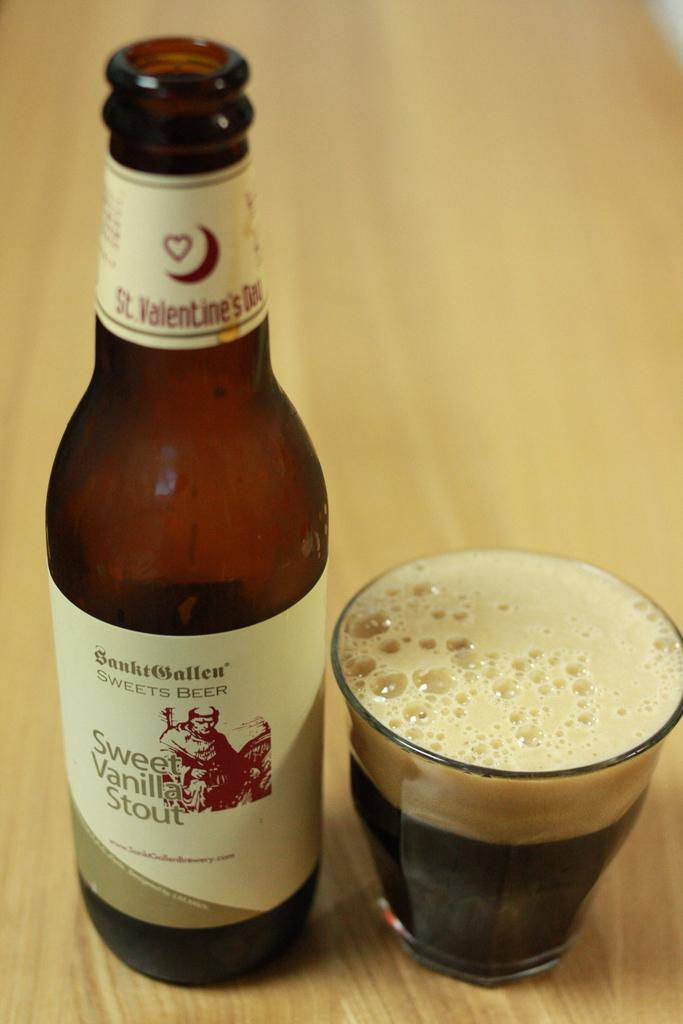<image>
Relay a brief, clear account of the picture shown. A bottle of sweet vanilla stout sits next to a full glass on a wooden table. 